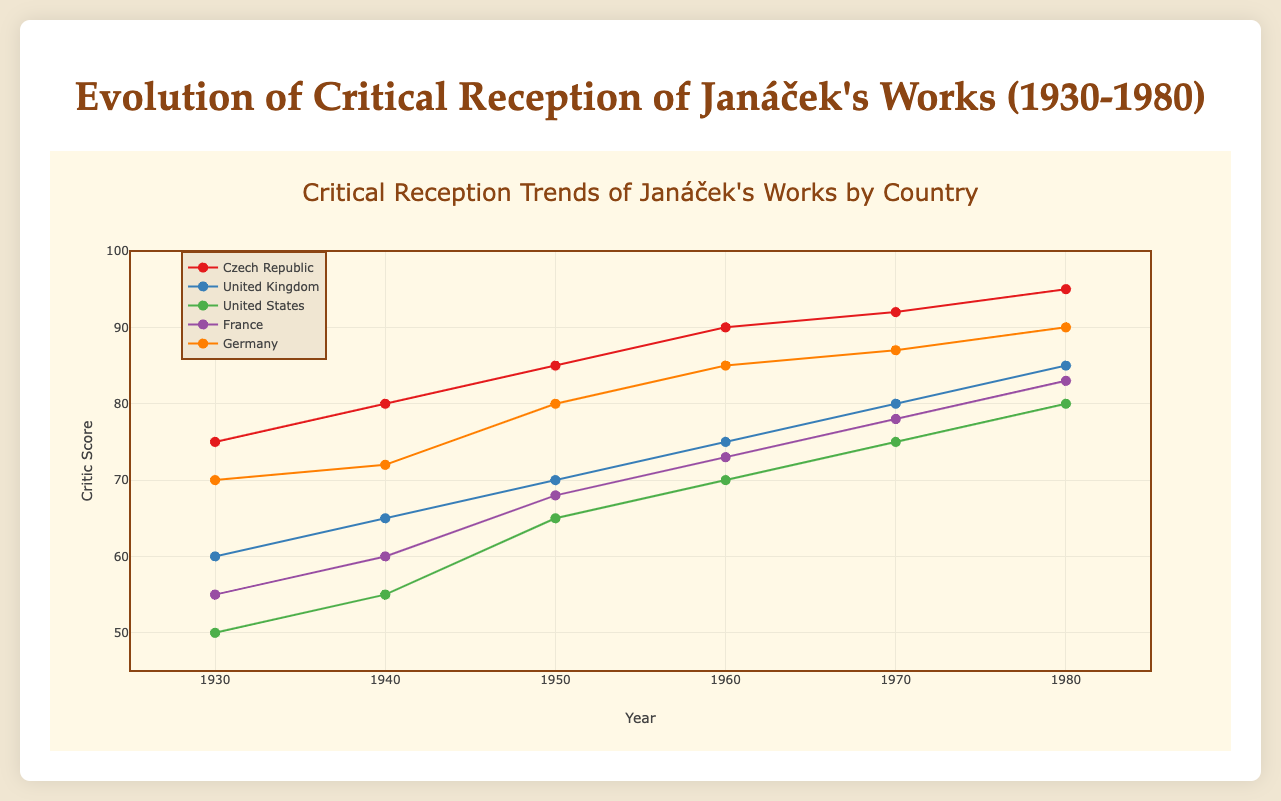What is the range of critic scores from the Czech Republic over the years? The Czech Republic's critic scores range from 75 in 1930 to 95 in 1980. The visual data points plotted against these years help to identify the range.
Answer: 75 to 95 Which country had the highest initial critic score in 1930? Among the plotted data, Germany had the highest initial critic score in 1930 with a score of 70. This is determined by comparing the critic scores of all countries for the year 1930.
Answer: Germany By how many points did the critic score for the United States increase between 1930 and 1980? The critic score for the United States in 1930 was 50 and in 1980 it was 80. The increase is calculated by subtracting 50 from 80.
Answer: 30 points How does the rate of increase in critic scores for the Czech Republic compare to that of the United Kingdom from 1960 to 1980? The Czech Republic's score increases from 90 to 95, an increase of 5 points. The United Kingdom's score increases from 75 to 85, an increase of 10 points. Comparing these, the United Kingdom had a higher rate of increase.
Answer: Faster in the United Kingdom Which country had the most consistent growth in critic scores over the years? Germany's critic scores show a consistent upward trend with relatively similar increments at each decade, observed from the plotted trend lines. Visual consistency in the increments determines this.
Answer: Germany What was the highest critic score recorded in 1980 and by which country? The highest critic score recorded in 1980 is 95, by the Czech Republic. This is seen by comparing the scores of all countries for the year 1980.
Answer: 95, Czech Republic How many data points are represented for the United Kingdom in the figure? The United Kingdom has data points for each decade from 1930 to 1980, making it 6 data points in total.
Answer: 6 data points Is there any country that started with a lower critic score than the United States in 1930 but ended with a higher score in 1980? France started with a critic score of 55 in 1930 (lower than the US which had 50) and ended with a score of 83 in 1980 (higher than the US which had 80).
Answer: France What trend can you observe in the critic scores for France from 1930 to 1980? France's critic scores show a consistent upward trend, starting at 55 in 1930 and ending at 83 in 1980, with no decreases across the plotted decades.
Answer: Consistent upward trend 